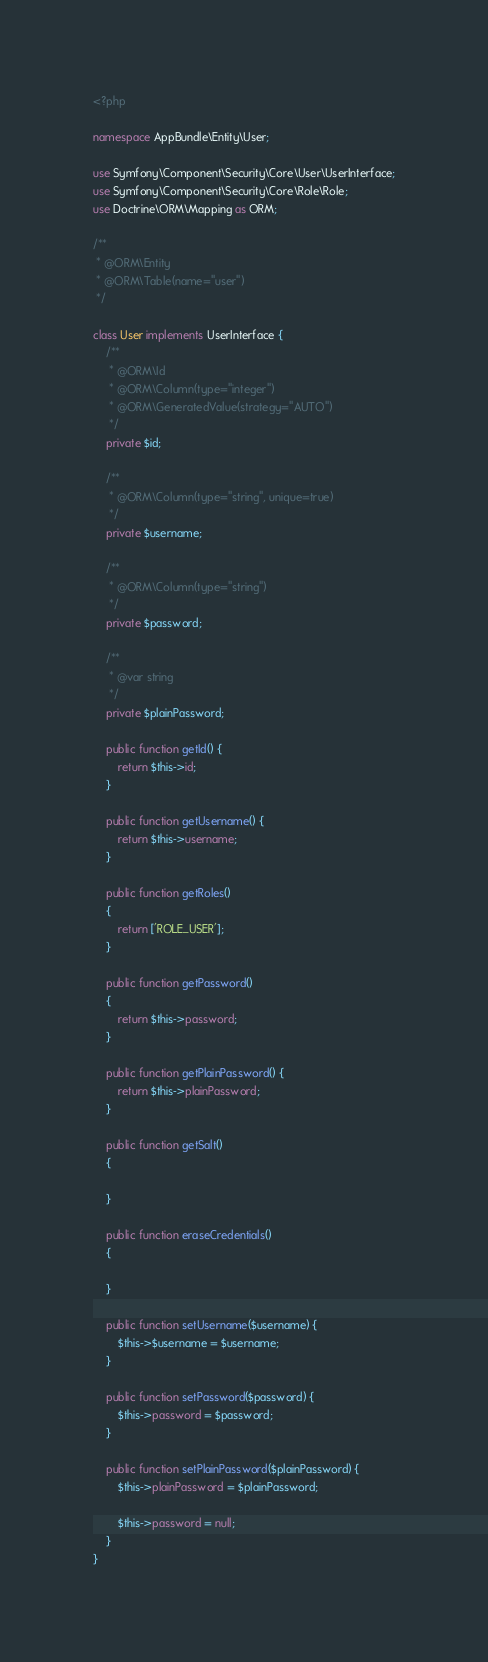<code> <loc_0><loc_0><loc_500><loc_500><_PHP_><?php

namespace AppBundle\Entity\User;

use Symfony\Component\Security\Core\User\UserInterface;
use Symfony\Component\Security\Core\Role\Role;
use Doctrine\ORM\Mapping as ORM;

/**
 * @ORM\Entity
 * @ORM\Table(name="user")
 */

class User implements UserInterface {
    /**
     * @ORM\Id
     * @ORM\Column(type="integer")
     * @ORM\GeneratedValue(strategy="AUTO")
     */
    private $id;

    /**
     * @ORM\Column(type="string", unique=true)
     */
    private $username;

    /**
     * @ORM\Column(type="string")
     */
    private $password;

    /**
     * @var string
     */
    private $plainPassword;

    public function getId() {
        return $this->id;
    }

    public function getUsername() {
        return $this->username;
    }

    public function getRoles()
    {
        return ['ROLE_USER'];
    }

    public function getPassword()
    {
        return $this->password;
    }

    public function getPlainPassword() {
        return $this->plainPassword;
    }

    public function getSalt()
    {
        
    }

    public function eraseCredentials()
    {
        
    }

    public function setUsername($username) {
        $this->$username = $username;
    }

    public function setPassword($password) {
        $this->password = $password;
    }

    public function setPlainPassword($plainPassword) {
        $this->plainPassword = $plainPassword;

        $this->password = null;
    }
}</code> 